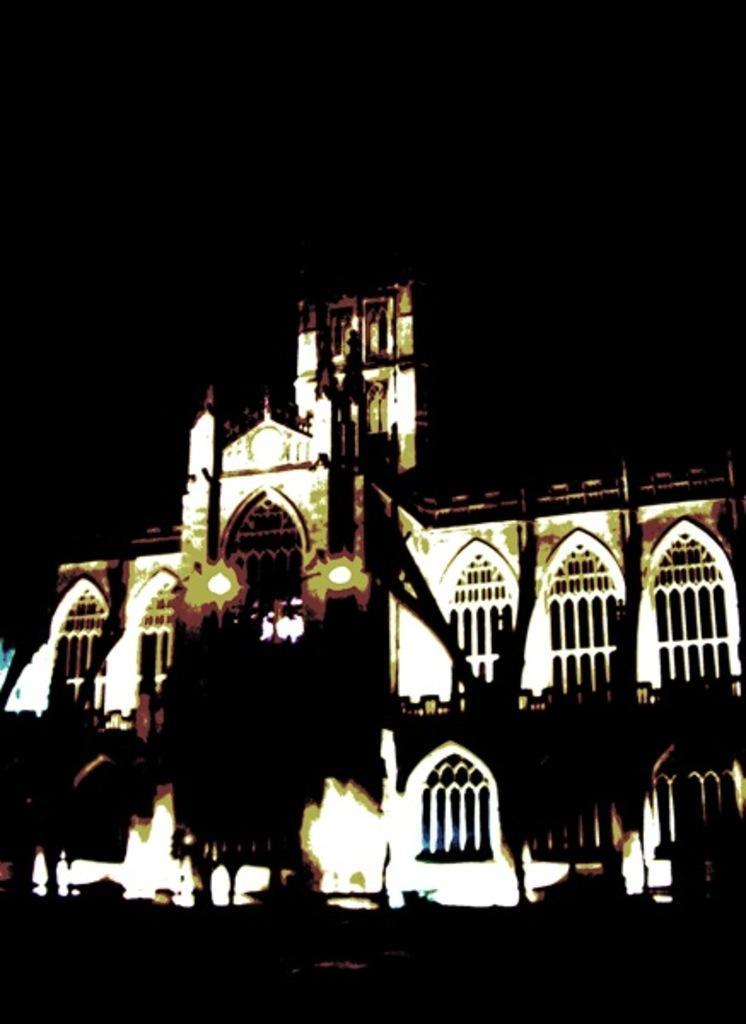Describe this image in one or two sentences. Here in this picture we can see a building present over there and we can see windows of the building and we can see lamp posts also present over there. 